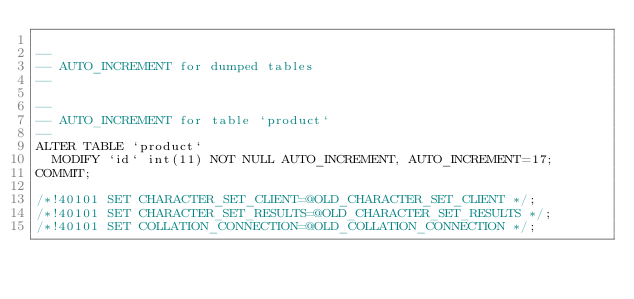<code> <loc_0><loc_0><loc_500><loc_500><_SQL_>
--
-- AUTO_INCREMENT for dumped tables
--

--
-- AUTO_INCREMENT for table `product`
--
ALTER TABLE `product`
  MODIFY `id` int(11) NOT NULL AUTO_INCREMENT, AUTO_INCREMENT=17;
COMMIT;

/*!40101 SET CHARACTER_SET_CLIENT=@OLD_CHARACTER_SET_CLIENT */;
/*!40101 SET CHARACTER_SET_RESULTS=@OLD_CHARACTER_SET_RESULTS */;
/*!40101 SET COLLATION_CONNECTION=@OLD_COLLATION_CONNECTION */;
</code> 